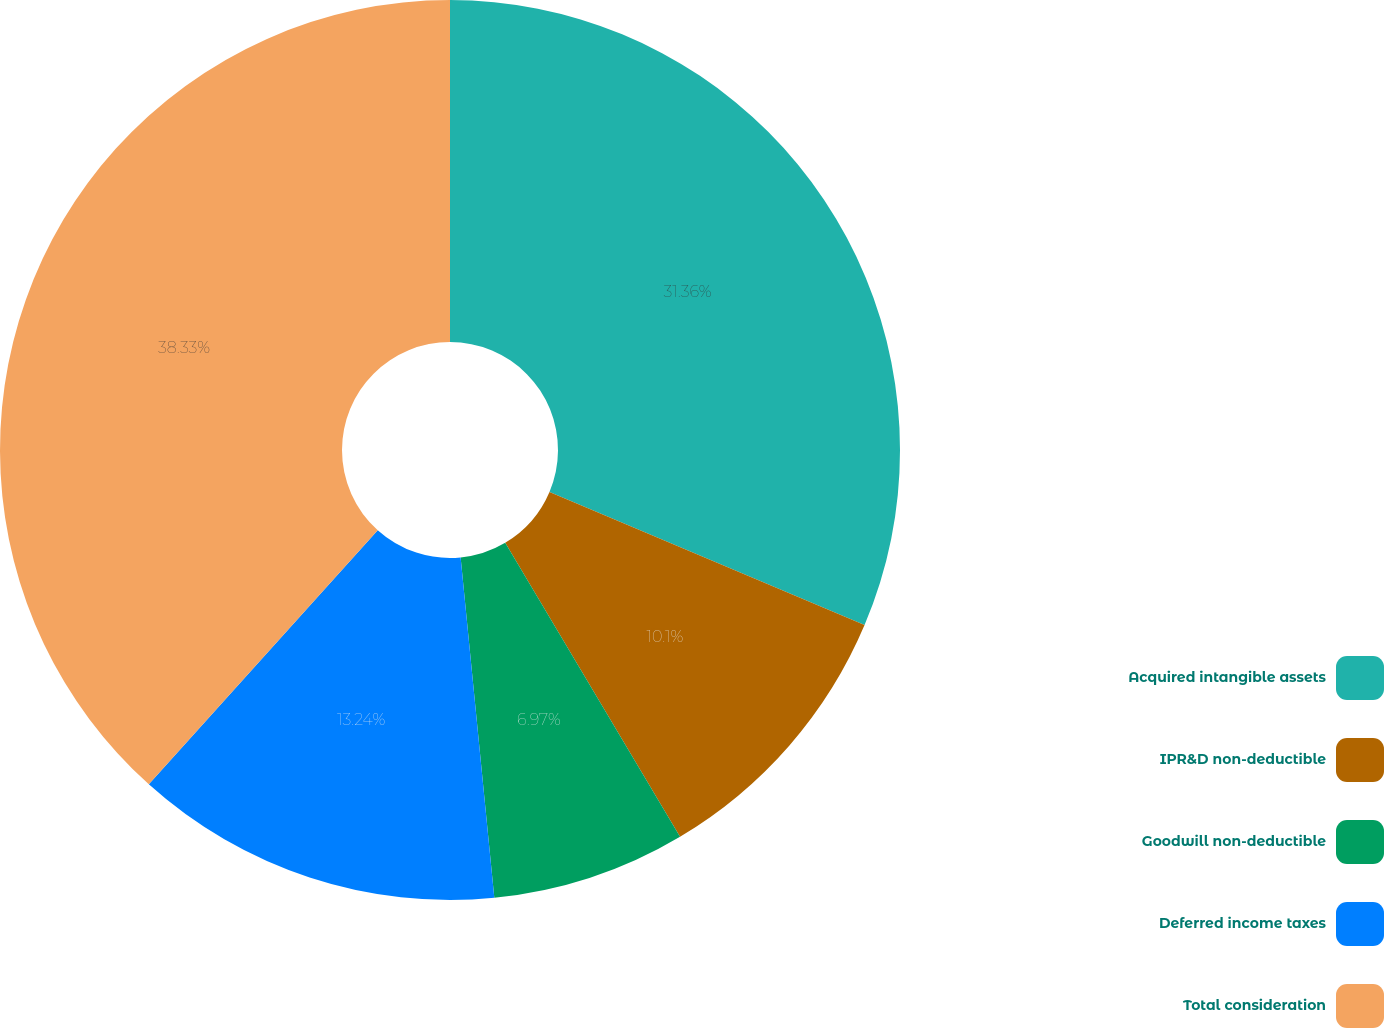Convert chart. <chart><loc_0><loc_0><loc_500><loc_500><pie_chart><fcel>Acquired intangible assets<fcel>IPR&D non-deductible<fcel>Goodwill non-deductible<fcel>Deferred income taxes<fcel>Total consideration<nl><fcel>31.36%<fcel>10.1%<fcel>6.97%<fcel>13.24%<fcel>38.33%<nl></chart> 